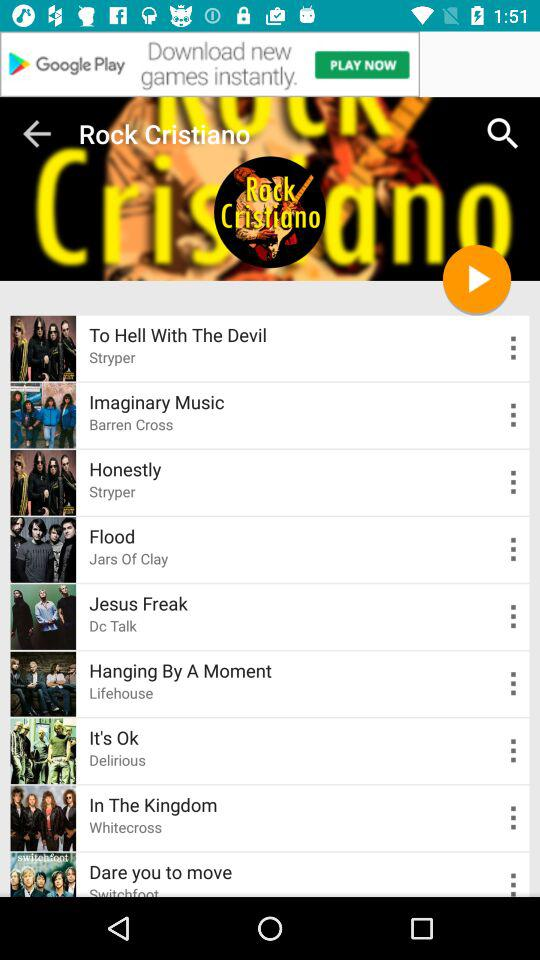Which song is sung by DC Talk? The song sung by Dc Talk is "Jesus Freak". 